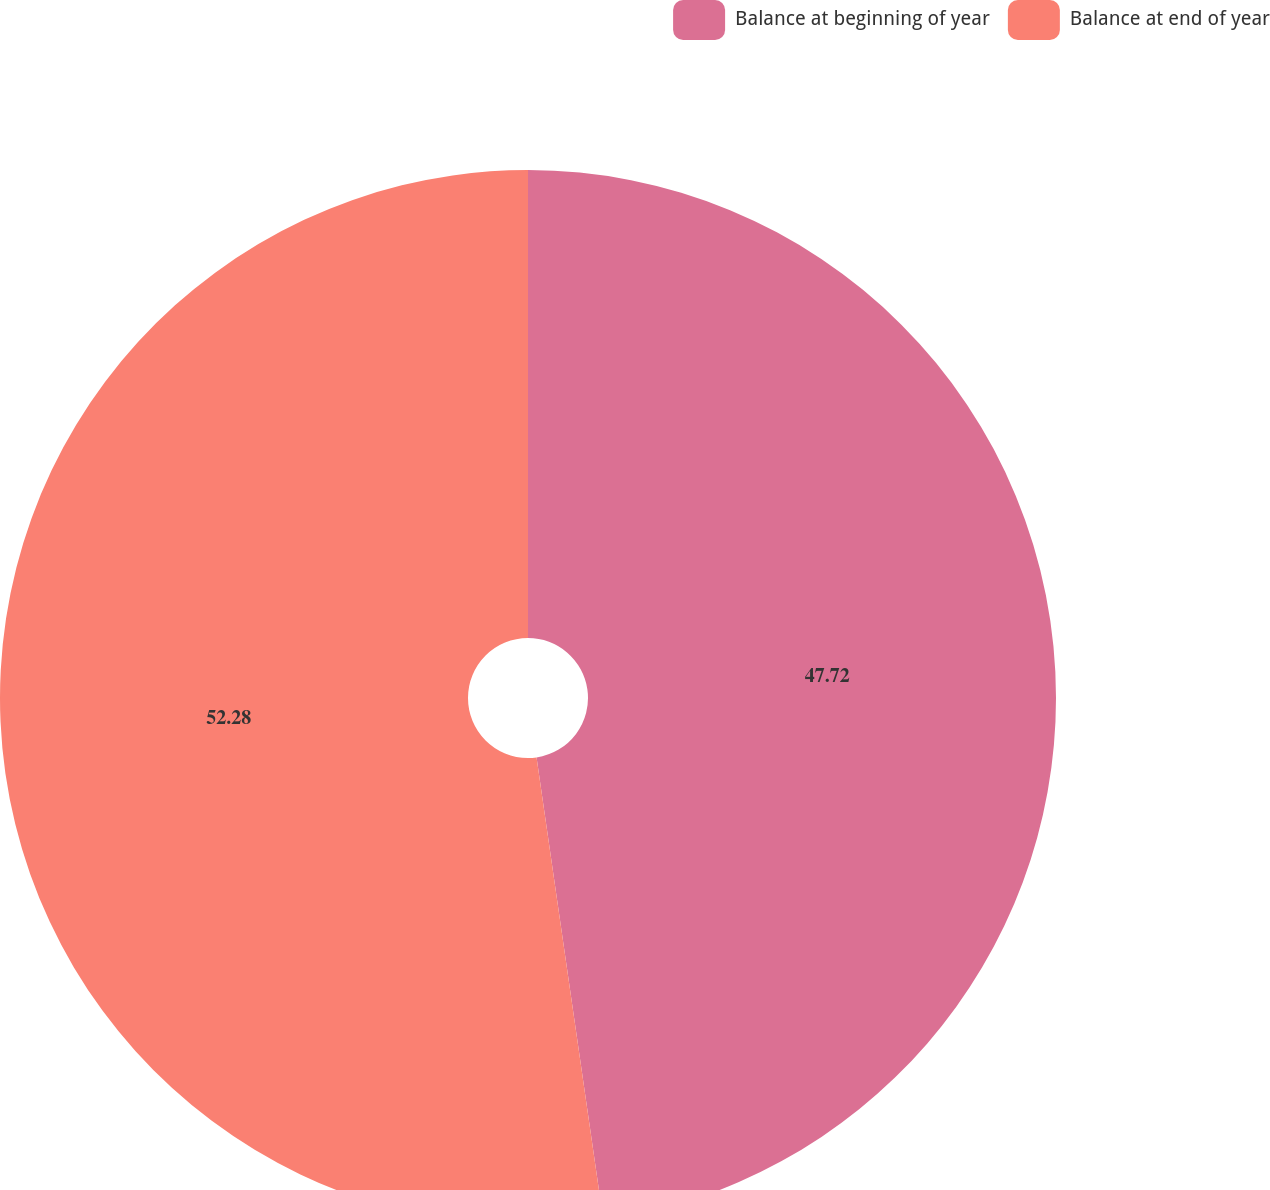<chart> <loc_0><loc_0><loc_500><loc_500><pie_chart><fcel>Balance at beginning of year<fcel>Balance at end of year<nl><fcel>47.72%<fcel>52.28%<nl></chart> 